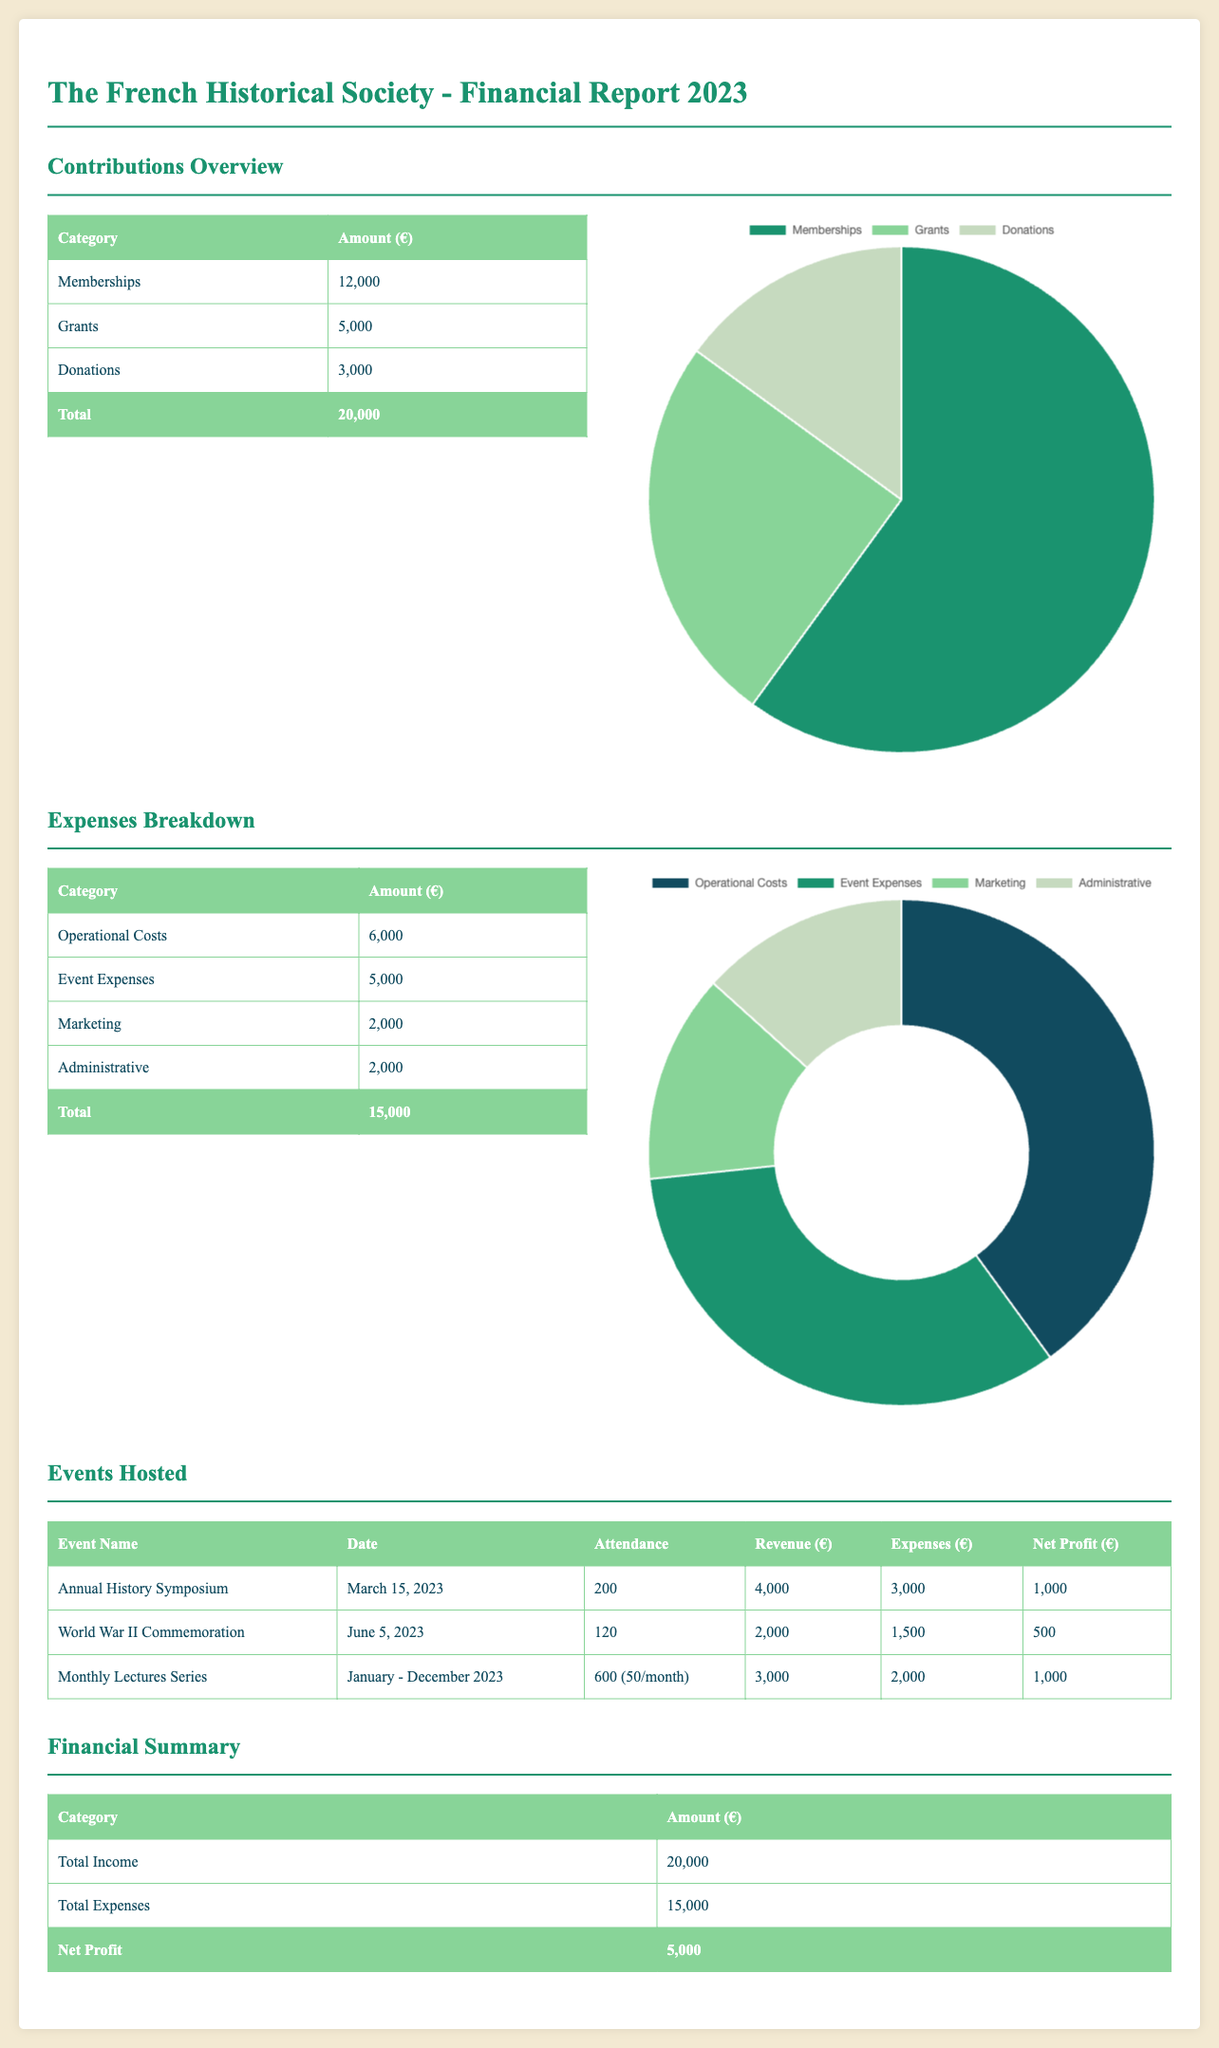What was the total amount received from memberships? The total amount received from memberships is listed in the contributions overview.
Answer: 12,000 What were the total expenses for the year? The total expenses for the year are summed in the expenses breakdown.
Answer: 15,000 What is the net profit for the year? The net profit is calculated from total income and total expenses in the financial summary.
Answer: 5,000 How many events were hosted throughout the year? The document lists three events hosted during the year.
Answer: 3 What is the attendance at the Annual History Symposium? The attendance of the Annual History Symposium is indicated in the events hosted section.
Answer: 200 Which category received the highest contributions? The highest contributions category can be identified from the contributions table.
Answer: Memberships What were the expenses for the World War II Commemoration? The expenses for the World War II Commemoration are listed in the events hosted section.
Answer: 1,500 What was the date of the Monthly Lectures Series? The date of the Monthly Lectures Series is specified in the events hosted table.
Answer: January - December 2023 What was the revenue generated by the Monthly Lectures Series? The revenue generated by the Monthly Lectures Series can be found in the events hosted section.
Answer: 3,000 